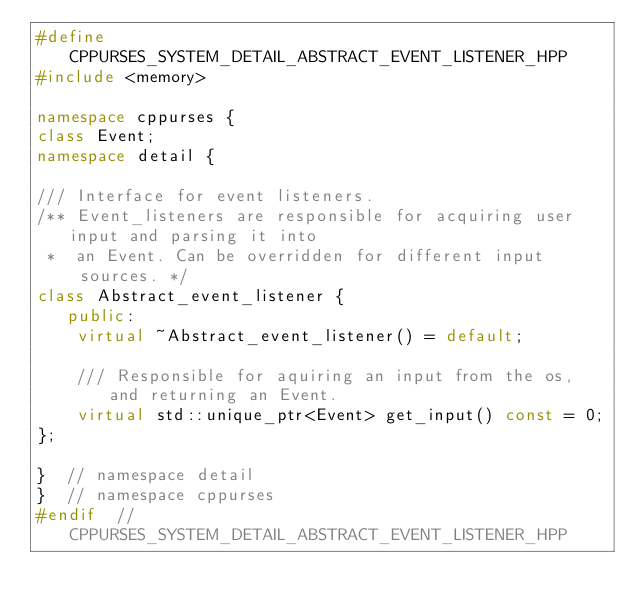Convert code to text. <code><loc_0><loc_0><loc_500><loc_500><_C++_>#define CPPURSES_SYSTEM_DETAIL_ABSTRACT_EVENT_LISTENER_HPP
#include <memory>

namespace cppurses {
class Event;
namespace detail {

/// Interface for event listeners.
/** Event_listeners are responsible for acquiring user input and parsing it into
 *  an Event. Can be overridden for different input sources. */
class Abstract_event_listener {
   public:
    virtual ~Abstract_event_listener() = default;

    /// Responsible for aquiring an input from the os, and returning an Event.
    virtual std::unique_ptr<Event> get_input() const = 0;
};

}  // namespace detail
}  // namespace cppurses
#endif  // CPPURSES_SYSTEM_DETAIL_ABSTRACT_EVENT_LISTENER_HPP
</code> 